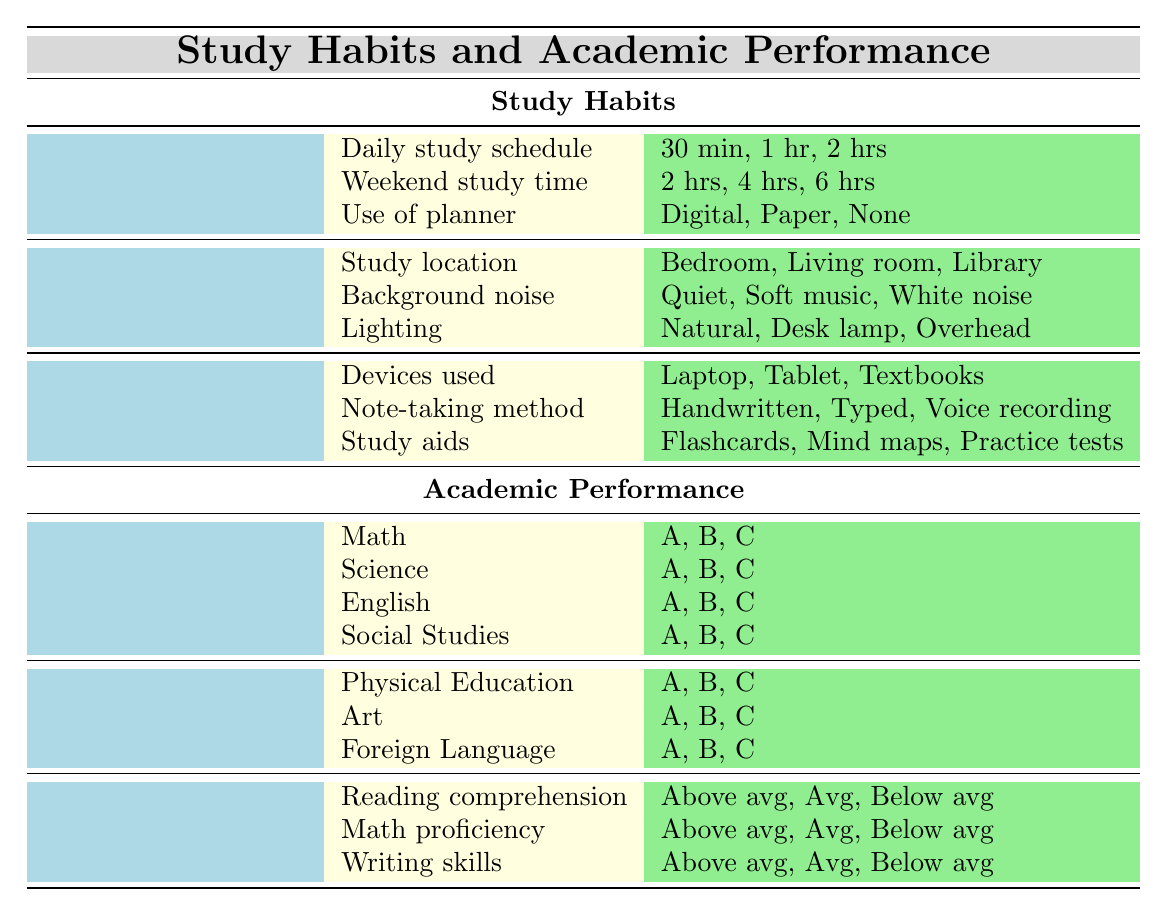What's the study location most commonly used by students? The table lists three study locations under "Study Habits" → "Environment," which are Bedroom, Living Room, and Library. However, it does not specify which is the most commonly used; it simply presents the options.
Answer: Not specified What are the available types of study aids listed in the table? Under "Study Habits" → "Tools," the study aids listed are Flashcards, Mind maps, and Practice tests.
Answer: Flashcards, Mind maps, Practice tests Is there a category for Extracurricular Activities in the table? The table includes a section titled "Extracurricular Activities," detailing Sports, Arts, and Academic clubs.
Answer: Yes Which note-taking method appears in the study habits section? The note-taking methods listed under "Tools" in the study habits section include Handwritten, Typed, and Voice recording.
Answer: Handwritten, Typed, Voice recording What is the highest possible grade a student can achieve in core subjects? The table lists grades A, B, and C for core subjects. The highest grade among these is A.
Answer: A How many different environments for studying are provided? The table specifies three study environments: Bedroom, Living room, and Library. Therefore, the total count of different environments is three.
Answer: 3 Is it true that all core subjects have a grade C option? The table indicates that core subjects Math, Science, English, and Social Studies each have grades A, B, and C listed, confirming the presence of a grade C option for all.
Answer: Yes What are the three types of devices used for studying? Under "Study Habits" → "Tools," the devices mentioned are Laptop, Tablet, and Textbooks.
Answer: Laptop, Tablet, Textbooks If a student spends 1 hour on homework assistance, how does this compare to 30 minutes? The time spent on homework assistance includes options for 15 minutes, 30 minutes, and 1 hour, showing that 1 hour is double that of 30 minutes, indicating a longer commitment to homework.
Answer: 1 hour is double 30 minutes Which standardized test skill has "Below average" as an option? In the "Academic Performance" → "Standardized Tests" section, the skills listed as "Above average," "Average," and "Below average," are Reading comprehension, Math proficiency, and Writing skills, confirming that all three have the "Below average" option.
Answer: Reading comprehension, Math proficiency, Writing skills 